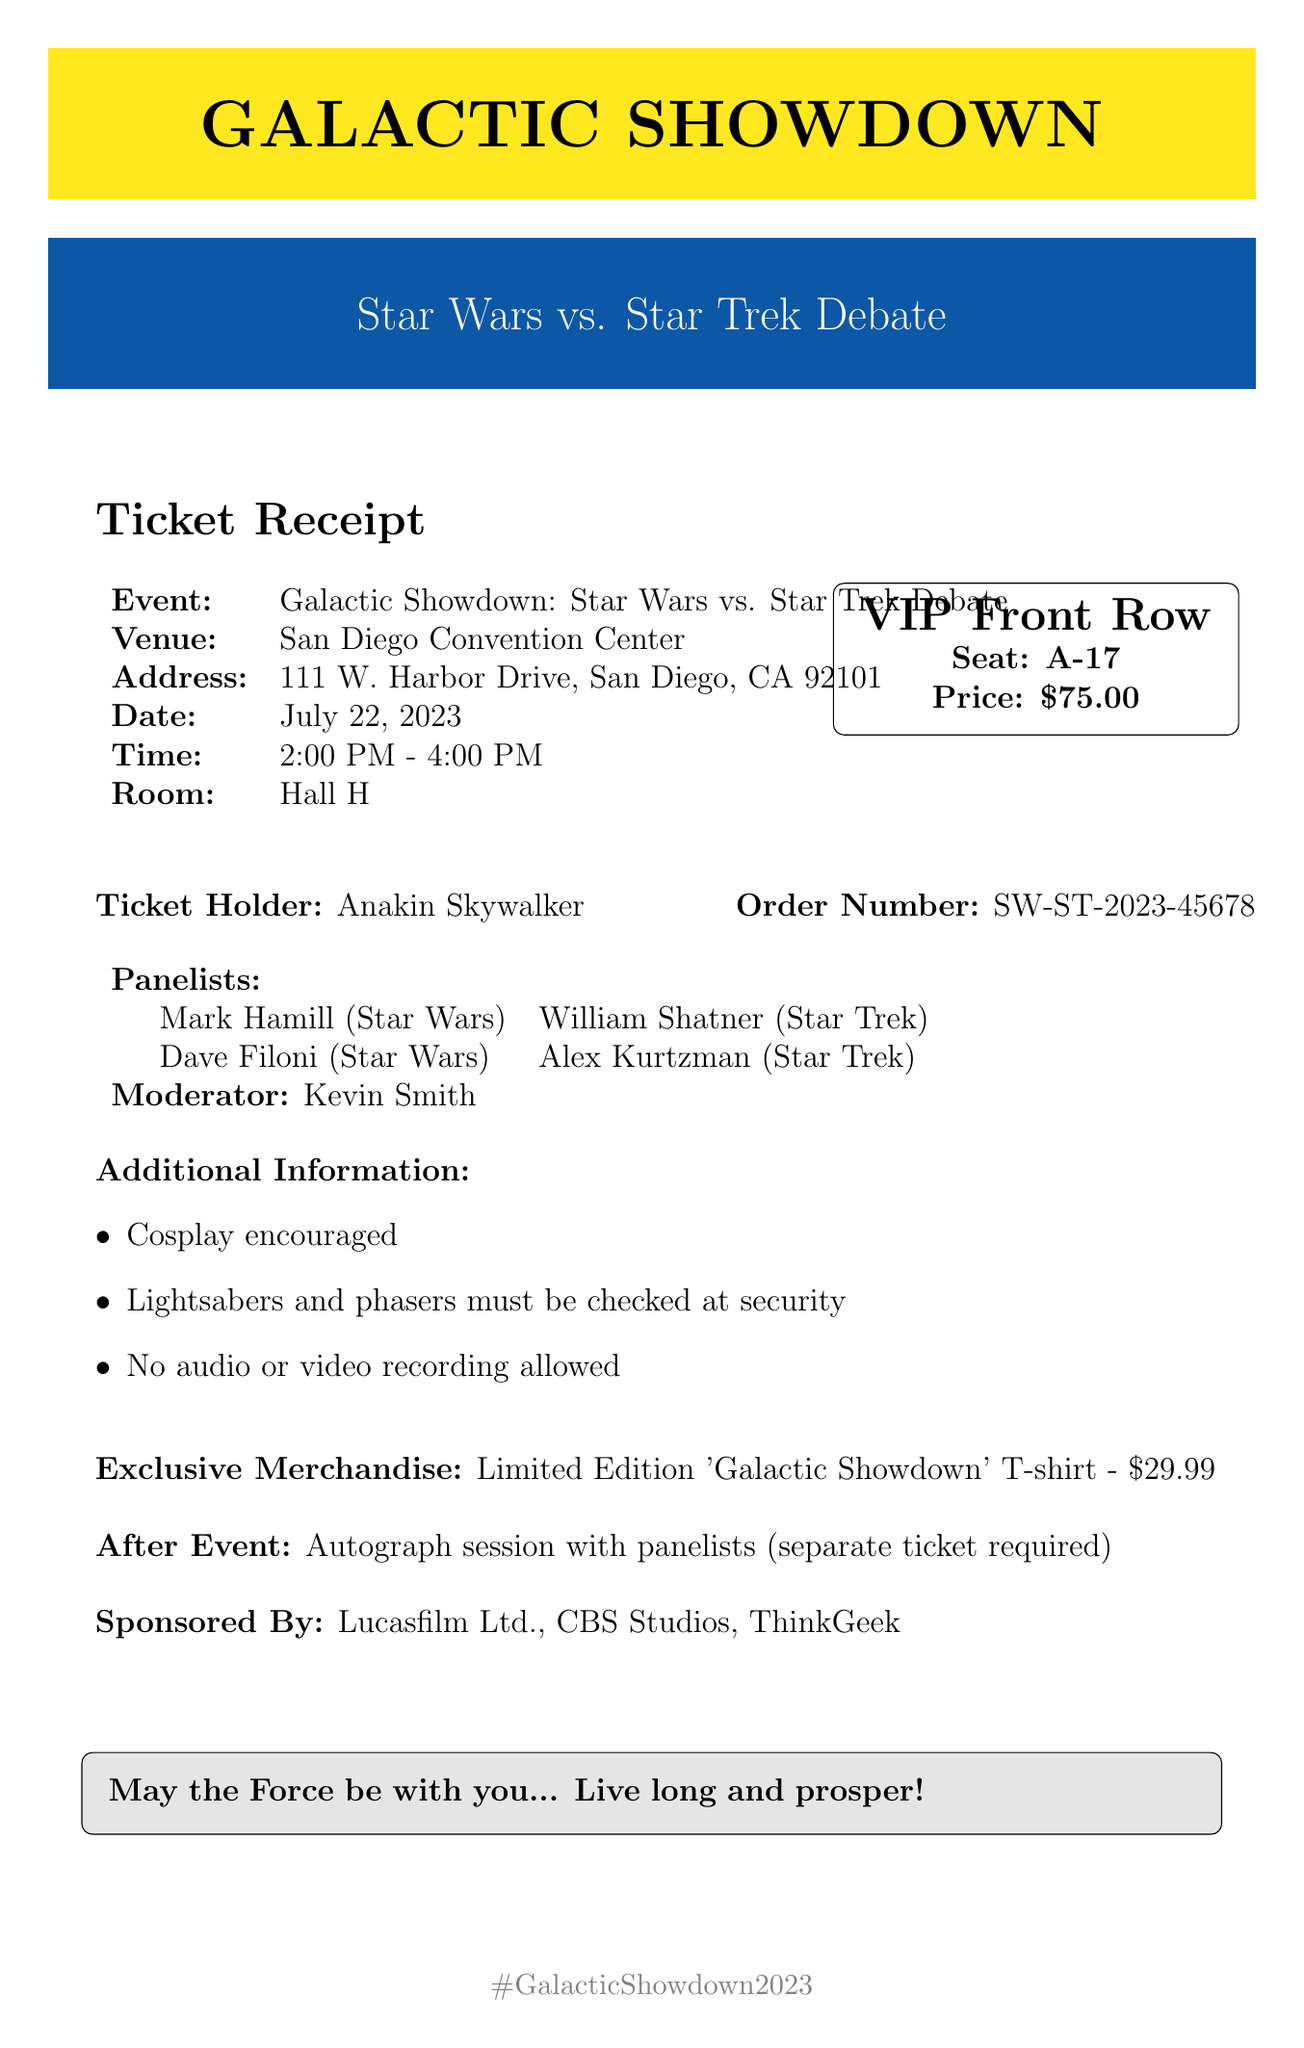What is the event name? The event name is presented prominently at the top of the document, which states "Galactic Showdown: Star Wars vs. Star Trek Debate."
Answer: Galactic Showdown: Star Wars vs. Star Trek Debate What is the seating area for the ticket? The document specifies the seating details, indicating the seat number as "A-17" in the VIP Front Row section.
Answer: A-17 What is the ticket price? The ticket price is clearly stated in the pricing section, listed as "$75.00."
Answer: $75.00 Who is the moderator of the panel? The document lists the moderator's name, which is necessary for understanding who will lead the discussion during the debate.
Answer: Kevin Smith What date is the event scheduled? The date of the event is provided, making it crucial for attendees to know when to attend.
Answer: July 22, 2023 How many panelists are featured? By counting the names listed in the document under "Panelists," one can determine the total number of panelists for the debate.
Answer: Four Is cosplay encouraged at the event? The document contains specific additional information which explicitly mentions whether cosplay is encouraged or discouraged at the event.
Answer: Yes What is the after-event activity? The document outlines what attendees can expect after the main event, including any activities planned.
Answer: Autograph session Is there exclusive merchandise available? The document notes if any special merchandise is available for purchase and what it entails.
Answer: Limited Edition 'Galactic Showdown' T-shirt 